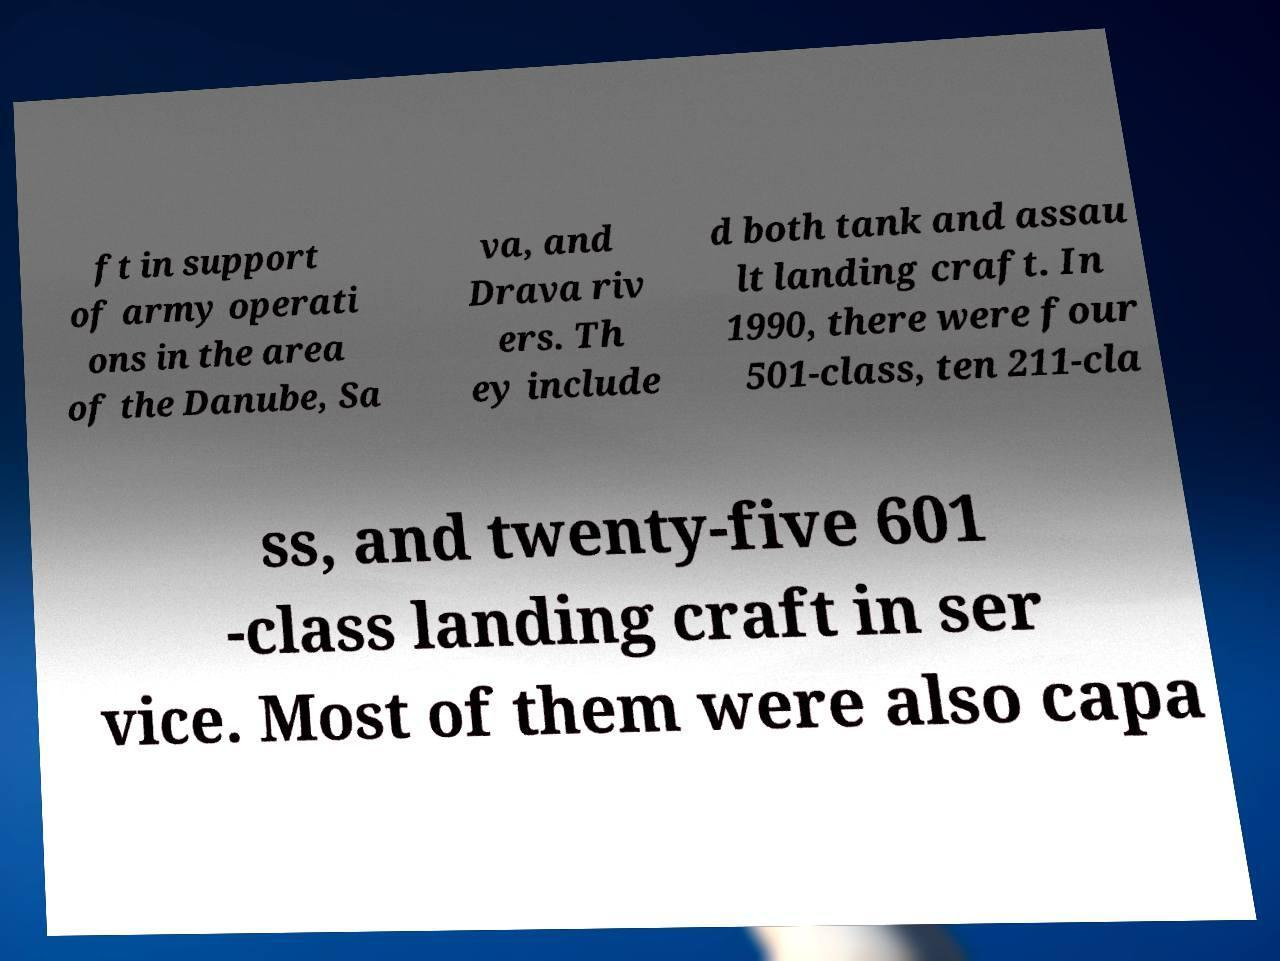Can you read and provide the text displayed in the image?This photo seems to have some interesting text. Can you extract and type it out for me? ft in support of army operati ons in the area of the Danube, Sa va, and Drava riv ers. Th ey include d both tank and assau lt landing craft. In 1990, there were four 501-class, ten 211-cla ss, and twenty-five 601 -class landing craft in ser vice. Most of them were also capa 